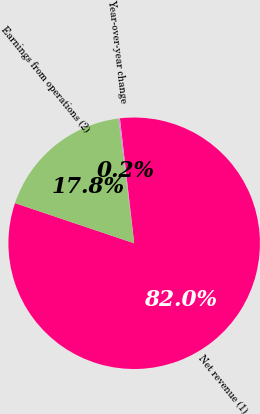Convert chart to OTSL. <chart><loc_0><loc_0><loc_500><loc_500><pie_chart><fcel>Net revenue (1)<fcel>Year-over-year change<fcel>Earnings from operations (2)<nl><fcel>81.98%<fcel>0.18%<fcel>17.84%<nl></chart> 